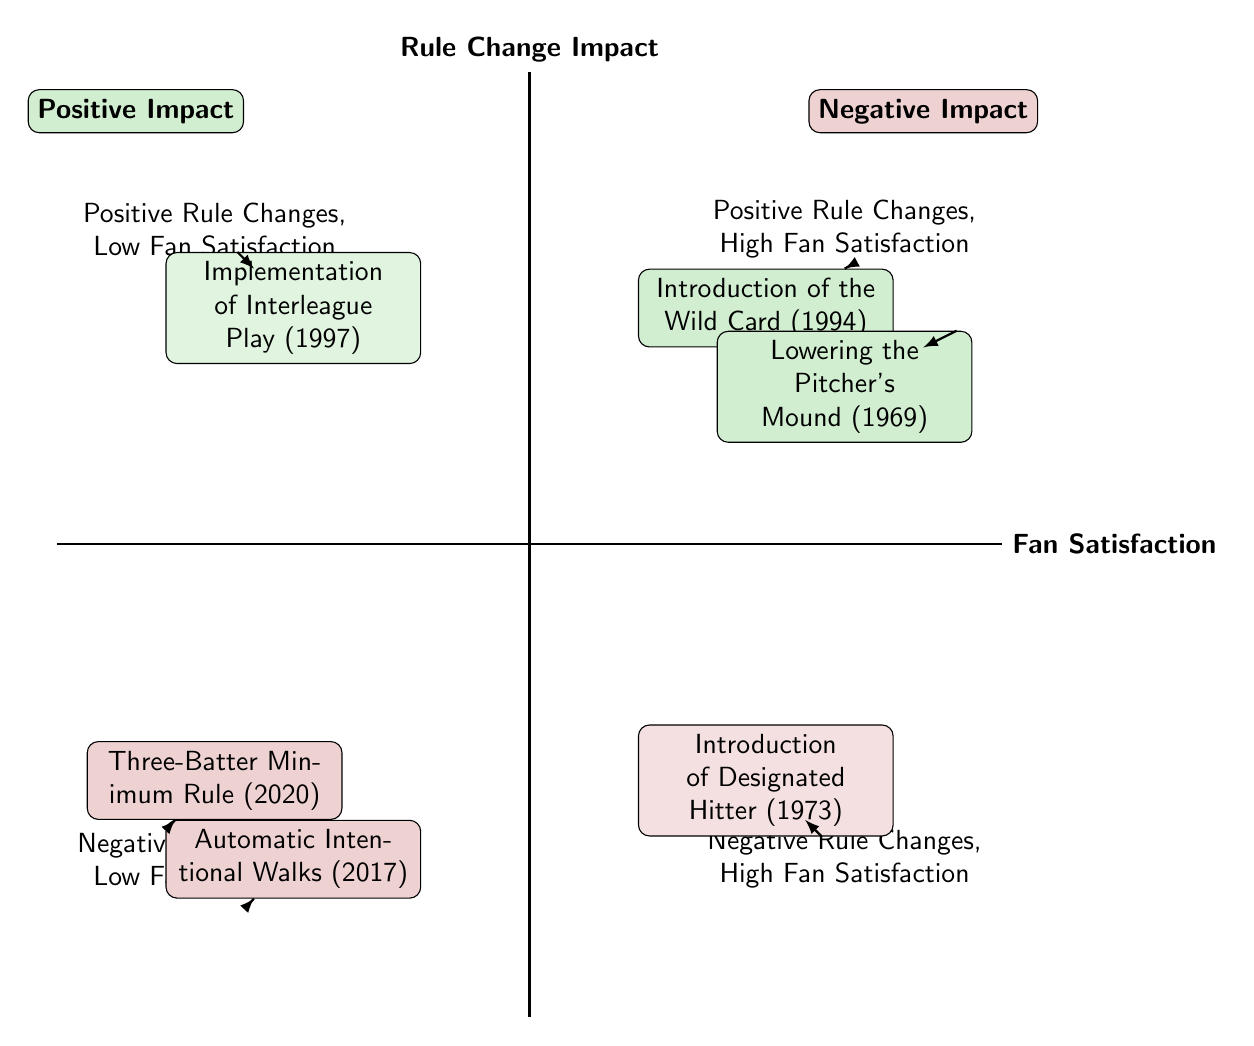What are the two rule changes in the "Positive Rule Changes, High Fan Satisfaction" quadrant? The "Positive Rule Changes, High Fan Satisfaction" quadrant contains two elements: 1) "Introduction of the Wild Card (1994)" and 2) "Lowering the Pitcher's Mound (1969)".
Answer: "Introduction of the Wild Card (1994)", "Lowering the Pitcher's Mound (1969)" How many rule changes are in the "Negative Rule Changes, Low Fan Satisfaction" quadrant? There are two rule changes in the "Negative Rule Changes, Low Fan Satisfaction" quadrant: 1) "Three-Batter Minimum Rule (2020)" and 2) "Automatic Intentional Walks (2017)".
Answer: 2 What type of fan satisfaction is associated with the "Implementation of Interleague Play (1997)"? The "Implementation of Interleague Play (1997)" is associated with "Mixed" fan satisfaction according to the diagram.
Answer: Mixed Which rule change is shown in the "Negative Rule Changes, High Fan Satisfaction" quadrant? The "Introduction of Designated Hitter (1973)" is the only rule change shown in the "Negative Rule Changes, High Fan Satisfaction" quadrant, and it is described as "Controversial, Initially High".
Answer: Introduction of Designated Hitter (1973) In which quadrant is the "Three-Batter Minimum Rule (2020)" located? The "Three-Batter Minimum Rule (2020)" is located in the "Negative Rule Changes, Low Fan Satisfaction" quadrant, where fan satisfaction is described as "Generally Negative".
Answer: Negative Rule Changes, Low Fan Satisfaction Which quadrant has positive impacts but low fan satisfaction? The quadrant titled "Positive Rule Changes, Low Fan Satisfaction" is where positive impacts from rule changes are associated with low fan satisfaction, exemplified by the "Implementation of Interleague Play (1997)".
Answer: Positive Rule Changes, Low Fan Satisfaction How does fan satisfaction for "Automatic Intentional Walks (2017)" compare to the "Three-Batter Minimum Rule (2020)"? Both "Automatic Intentional Walks (2017)" and "Three-Batter Minimum Rule (2020)" are in the "Negative Rule Changes, Low Fan Satisfaction" quadrant and have negative fan satisfaction ratings. However, "Automatic Intentional Walks (2017)" is described as "Mostly Negative", while "Three-Batter Minimum Rule (2020)" is "Generally Negative", indicating a slight difference in their reception.
Answer: Mostly Negative, Generally Negative Which positive rule change occurred in 1969? The positive rule change that occurred in 1969 is the "Lowering the Pitcher's Mound". It is placed in the "Positive Rule Changes, High Fan Satisfaction" quadrant, where fan satisfaction is termed as "Positive".
Answer: Lowering the Pitcher's Mound (1969) 